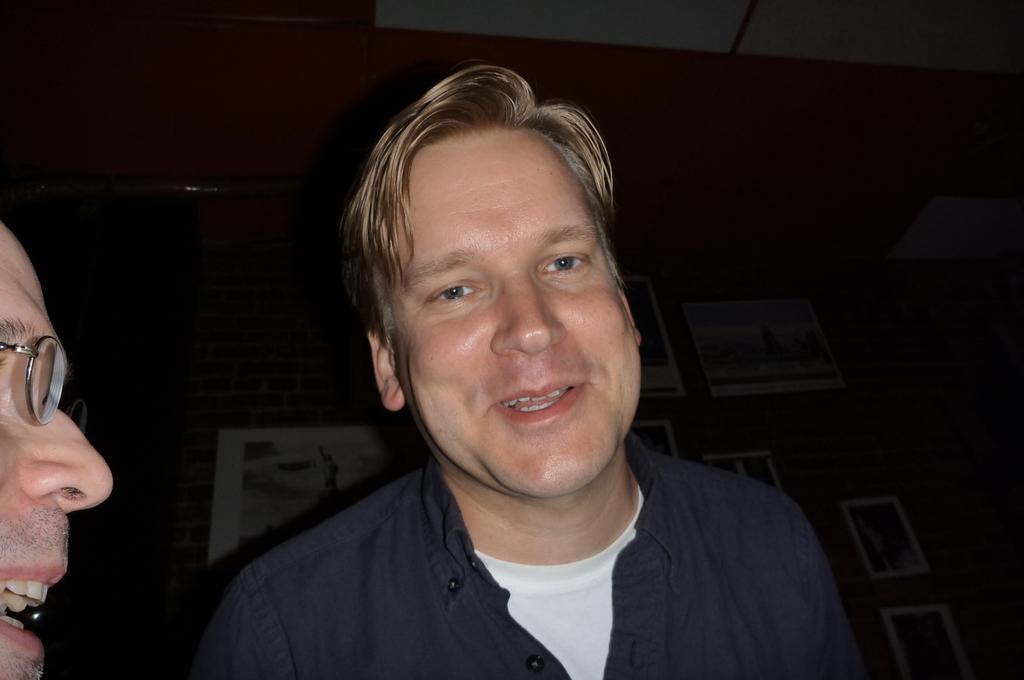Could you give a brief overview of what you see in this image? In this image we can see two people, behind them there is a wall with picture frames. 